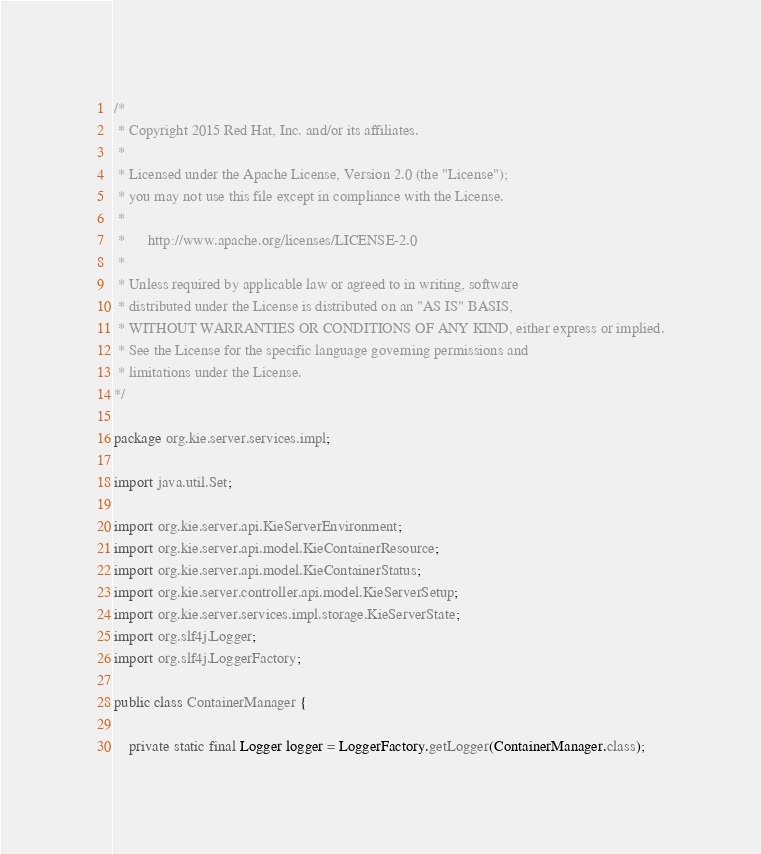Convert code to text. <code><loc_0><loc_0><loc_500><loc_500><_Java_>/*
 * Copyright 2015 Red Hat, Inc. and/or its affiliates.
 *
 * Licensed under the Apache License, Version 2.0 (the "License");
 * you may not use this file except in compliance with the License.
 *
 *      http://www.apache.org/licenses/LICENSE-2.0
 *
 * Unless required by applicable law or agreed to in writing, software
 * distributed under the License is distributed on an "AS IS" BASIS,
 * WITHOUT WARRANTIES OR CONDITIONS OF ANY KIND, either express or implied.
 * See the License for the specific language governing permissions and
 * limitations under the License.
*/

package org.kie.server.services.impl;

import java.util.Set;

import org.kie.server.api.KieServerEnvironment;
import org.kie.server.api.model.KieContainerResource;
import org.kie.server.api.model.KieContainerStatus;
import org.kie.server.controller.api.model.KieServerSetup;
import org.kie.server.services.impl.storage.KieServerState;
import org.slf4j.Logger;
import org.slf4j.LoggerFactory;

public class ContainerManager {

    private static final Logger logger = LoggerFactory.getLogger(ContainerManager.class);
</code> 